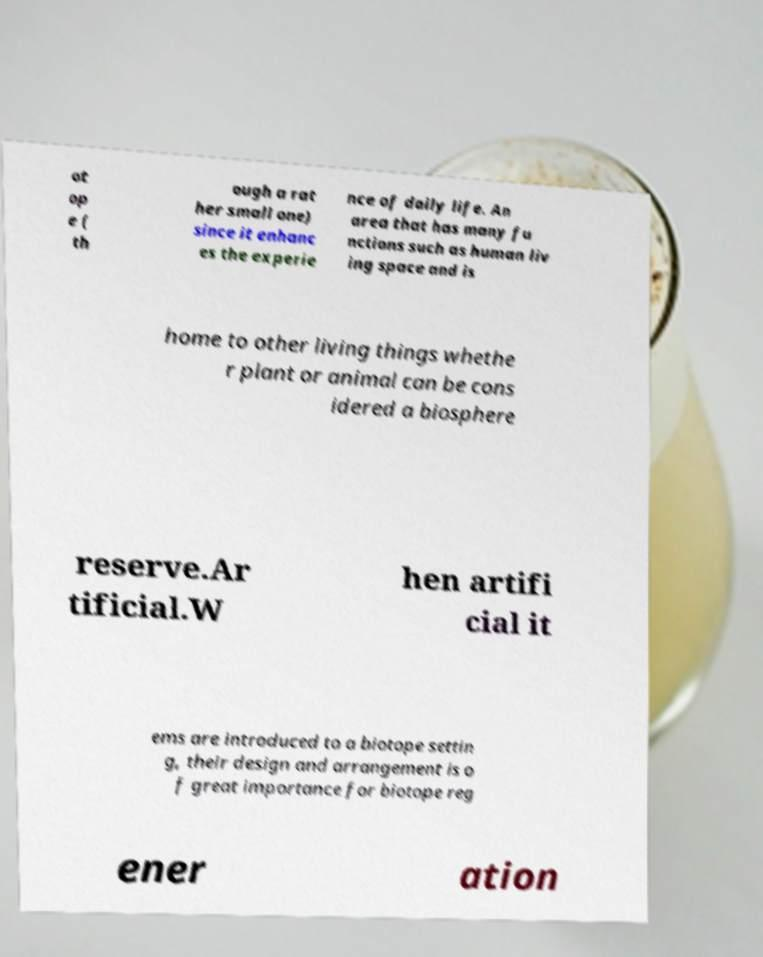Can you read and provide the text displayed in the image?This photo seems to have some interesting text. Can you extract and type it out for me? ot op e ( th ough a rat her small one) since it enhanc es the experie nce of daily life. An area that has many fu nctions such as human liv ing space and is home to other living things whethe r plant or animal can be cons idered a biosphere reserve.Ar tificial.W hen artifi cial it ems are introduced to a biotope settin g, their design and arrangement is o f great importance for biotope reg ener ation 